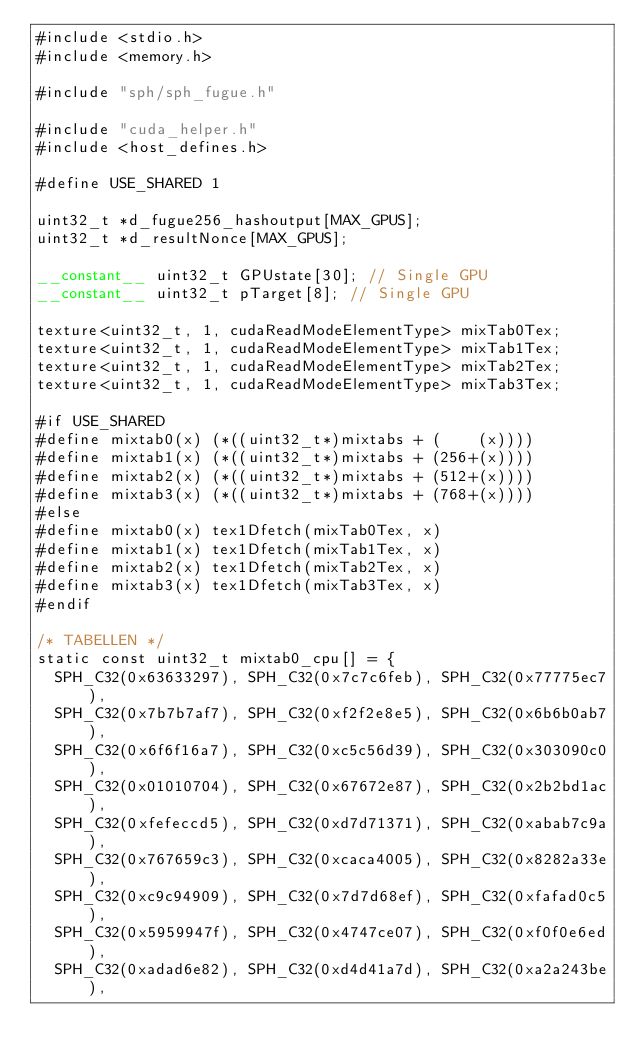<code> <loc_0><loc_0><loc_500><loc_500><_Cuda_>#include <stdio.h>
#include <memory.h>

#include "sph/sph_fugue.h"

#include "cuda_helper.h"
#include <host_defines.h>

#define USE_SHARED 1

uint32_t *d_fugue256_hashoutput[MAX_GPUS];
uint32_t *d_resultNonce[MAX_GPUS];

__constant__ uint32_t GPUstate[30]; // Single GPU
__constant__ uint32_t pTarget[8]; // Single GPU

texture<uint32_t, 1, cudaReadModeElementType> mixTab0Tex;
texture<uint32_t, 1, cudaReadModeElementType> mixTab1Tex;
texture<uint32_t, 1, cudaReadModeElementType> mixTab2Tex;
texture<uint32_t, 1, cudaReadModeElementType> mixTab3Tex;

#if USE_SHARED
#define mixtab0(x) (*((uint32_t*)mixtabs + (    (x))))
#define mixtab1(x) (*((uint32_t*)mixtabs + (256+(x))))
#define mixtab2(x) (*((uint32_t*)mixtabs + (512+(x))))
#define mixtab3(x) (*((uint32_t*)mixtabs + (768+(x))))
#else
#define mixtab0(x) tex1Dfetch(mixTab0Tex, x)
#define mixtab1(x) tex1Dfetch(mixTab1Tex, x)
#define mixtab2(x) tex1Dfetch(mixTab2Tex, x)
#define mixtab3(x) tex1Dfetch(mixTab3Tex, x)
#endif

/* TABELLEN */
static const uint32_t mixtab0_cpu[] = {
	SPH_C32(0x63633297), SPH_C32(0x7c7c6feb), SPH_C32(0x77775ec7),
	SPH_C32(0x7b7b7af7), SPH_C32(0xf2f2e8e5), SPH_C32(0x6b6b0ab7),
	SPH_C32(0x6f6f16a7), SPH_C32(0xc5c56d39), SPH_C32(0x303090c0),
	SPH_C32(0x01010704), SPH_C32(0x67672e87), SPH_C32(0x2b2bd1ac),
	SPH_C32(0xfefeccd5), SPH_C32(0xd7d71371), SPH_C32(0xabab7c9a),
	SPH_C32(0x767659c3), SPH_C32(0xcaca4005), SPH_C32(0x8282a33e),
	SPH_C32(0xc9c94909), SPH_C32(0x7d7d68ef), SPH_C32(0xfafad0c5),
	SPH_C32(0x5959947f), SPH_C32(0x4747ce07), SPH_C32(0xf0f0e6ed),
	SPH_C32(0xadad6e82), SPH_C32(0xd4d41a7d), SPH_C32(0xa2a243be),</code> 